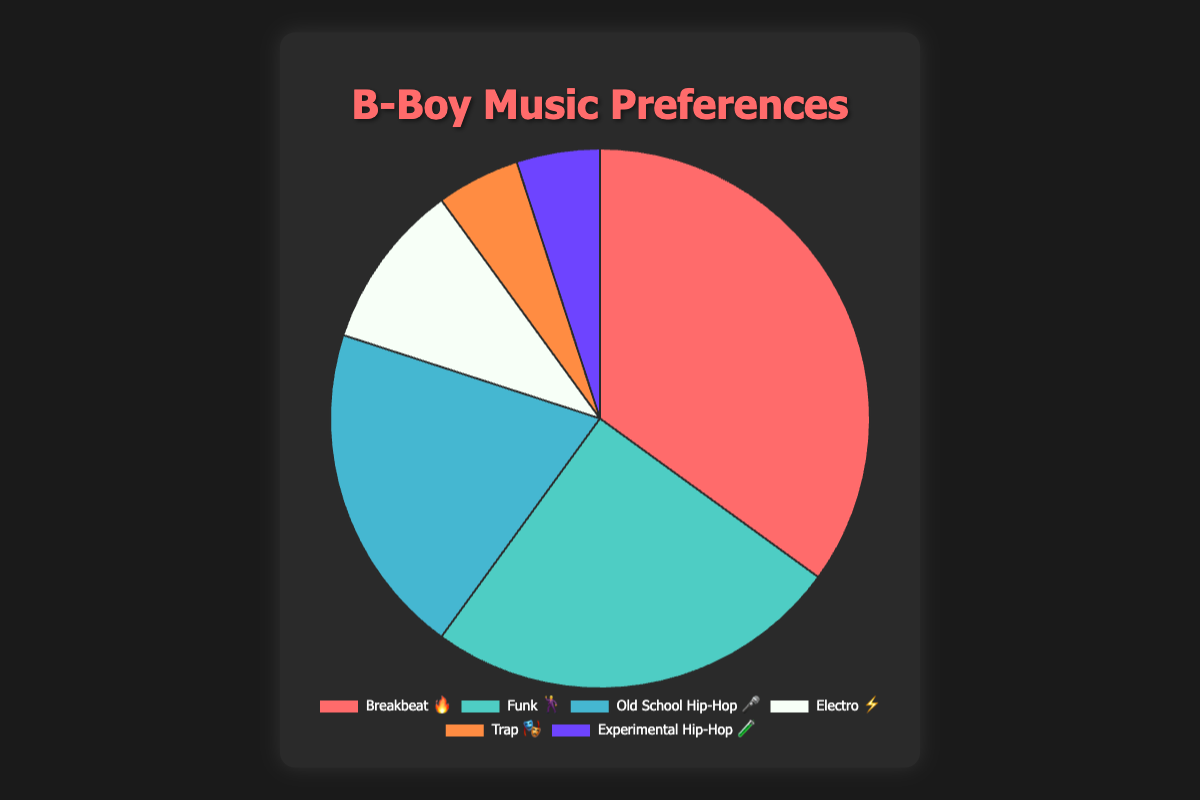what's the most preferred hip-hop genre by b-boys? The chart shows the percentage breakdown of different hip-hop genres preferred by b-boys. The genre with the highest percentage is the most preferred.
Answer: Breakbeat 🔥 with 35% what’s the least preferred hip-hop genre by b-boys? Looking at the chart, the genre with the lowest percentage is the least preferred. Both Trap and Experimental Hip-Hop have the same, lowest percentage of 5%.
Answer: Trap 🎭 and Experimental Hip-Hop 🧪 what's the combined percentage for Funk and Electro? The chart indicates that Funk has a 25% share and Electro has a 10% share. Adding these two percentages gives the combined percentage. 25% + 10% = 35%
Answer: 35% which emoji represents Old School Hip-Hop? The chart labels each genre with a corresponding emoji. By finding Old School Hip-Hop, we see it is labeled with the 🎤 emoji.
Answer: 🎤 how much more preferred is Breakbeat compared to Trap? The chart shows that Breakbeat has a 35% share while Trap has a 5% share. The difference in their preferences is calculated by subtracting Trap's percentage from Breakbeat's percentage. 35% - 5% = 30%
Answer: 30% which genre is preferred more: Electro or Experimental Hip-Hop? The chart shows the percentage for Electro is 10%, while Experimental Hip-Hop is 5%. Since 10% is greater than 5%, Electro is preferred more.
Answer: Electro ⚡ what's the total percentage of all hip-hop genres in the chart? Each genre's percentage must sum up to 100% because the chart represents the complete breakdown of preferences.
Answer: 100% how many genres are depicted in the chart? By counting the number of different genres listed in the chart, we find that there are six genres.
Answer: 6 what's the second most preferred genre after Breakbeat? According to the chart, Funk holds the second-highest percentage of 25%, right after Breakbeat.
Answer: Funk 🕺 which genres have an equal percentage of preference? Examining the chart, we see that both Trap and Experimental Hip-Hop have the same percentage of preference, 5%.
Answer: Trap 🎭 and Experimental Hip-Hop 🧪 